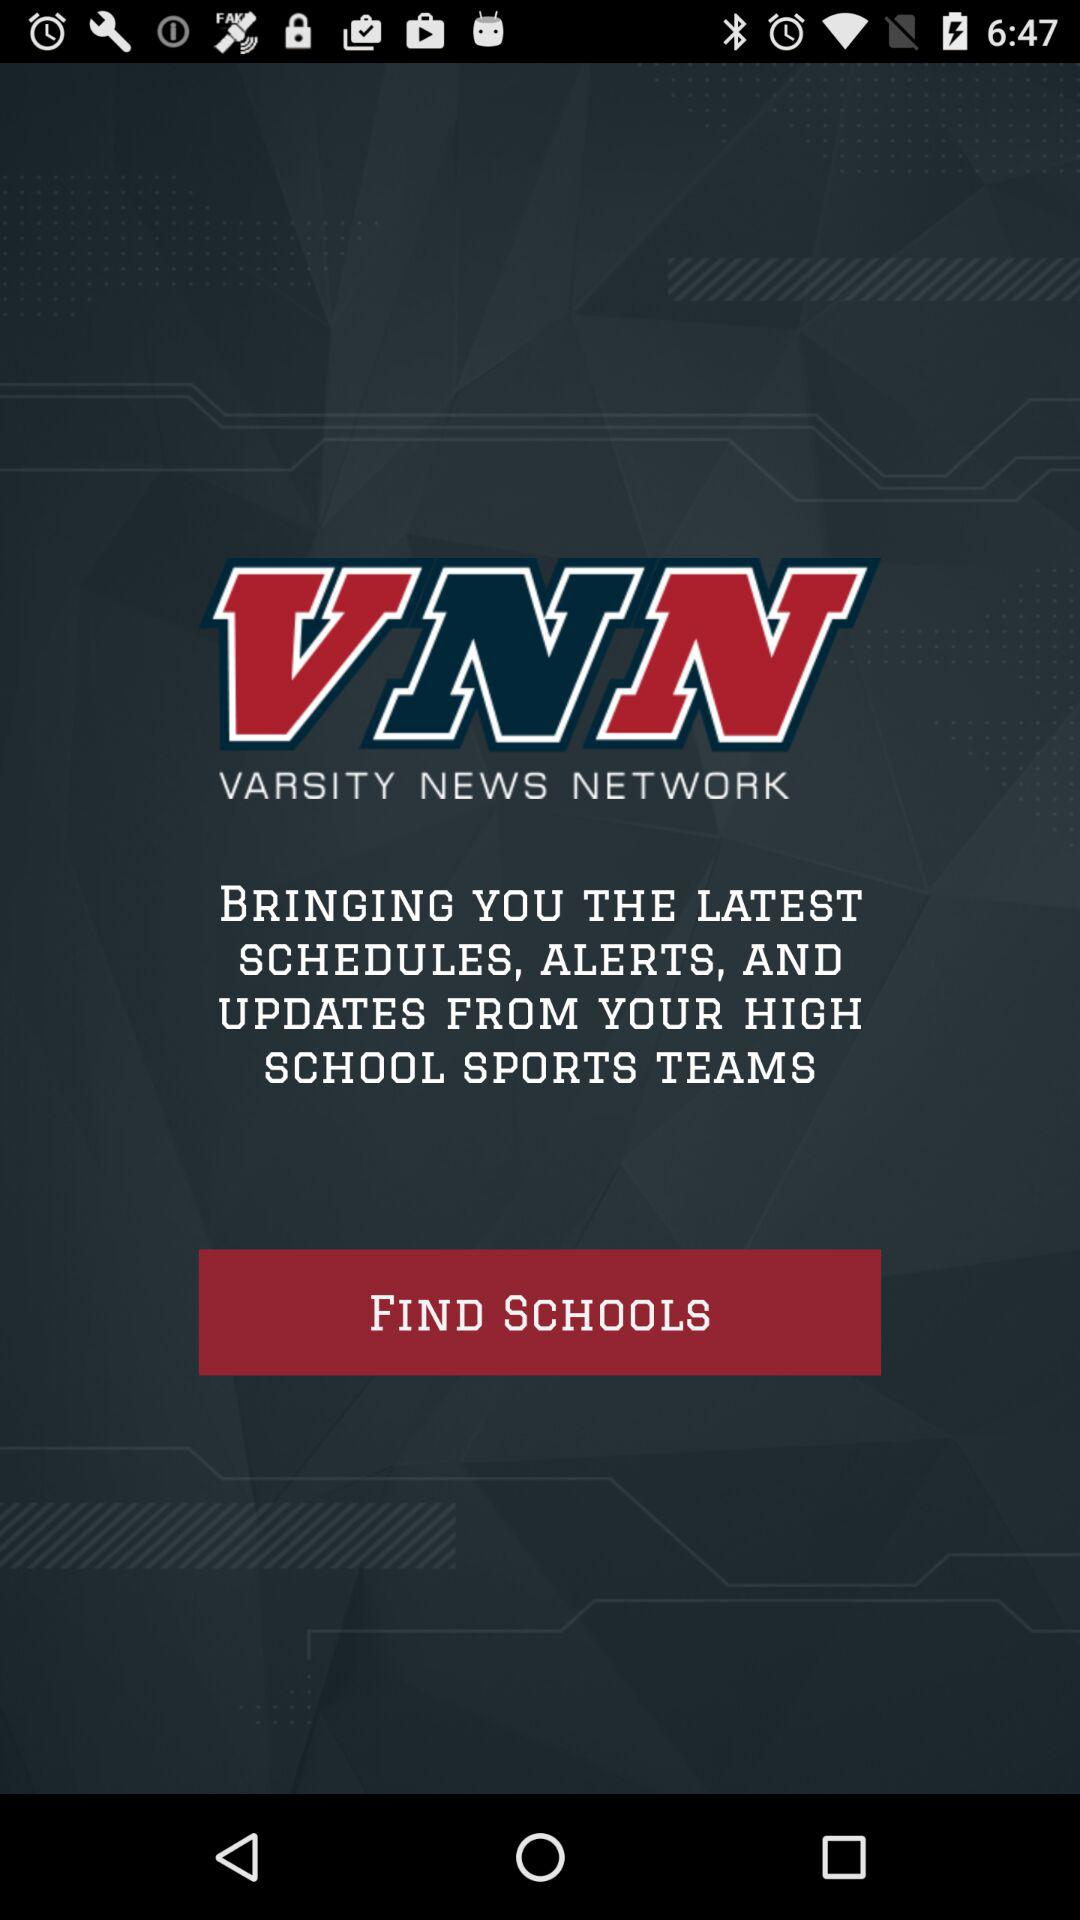What is the name of the developer? The name of the developer is "VARSITY NEWS NETWORK". 